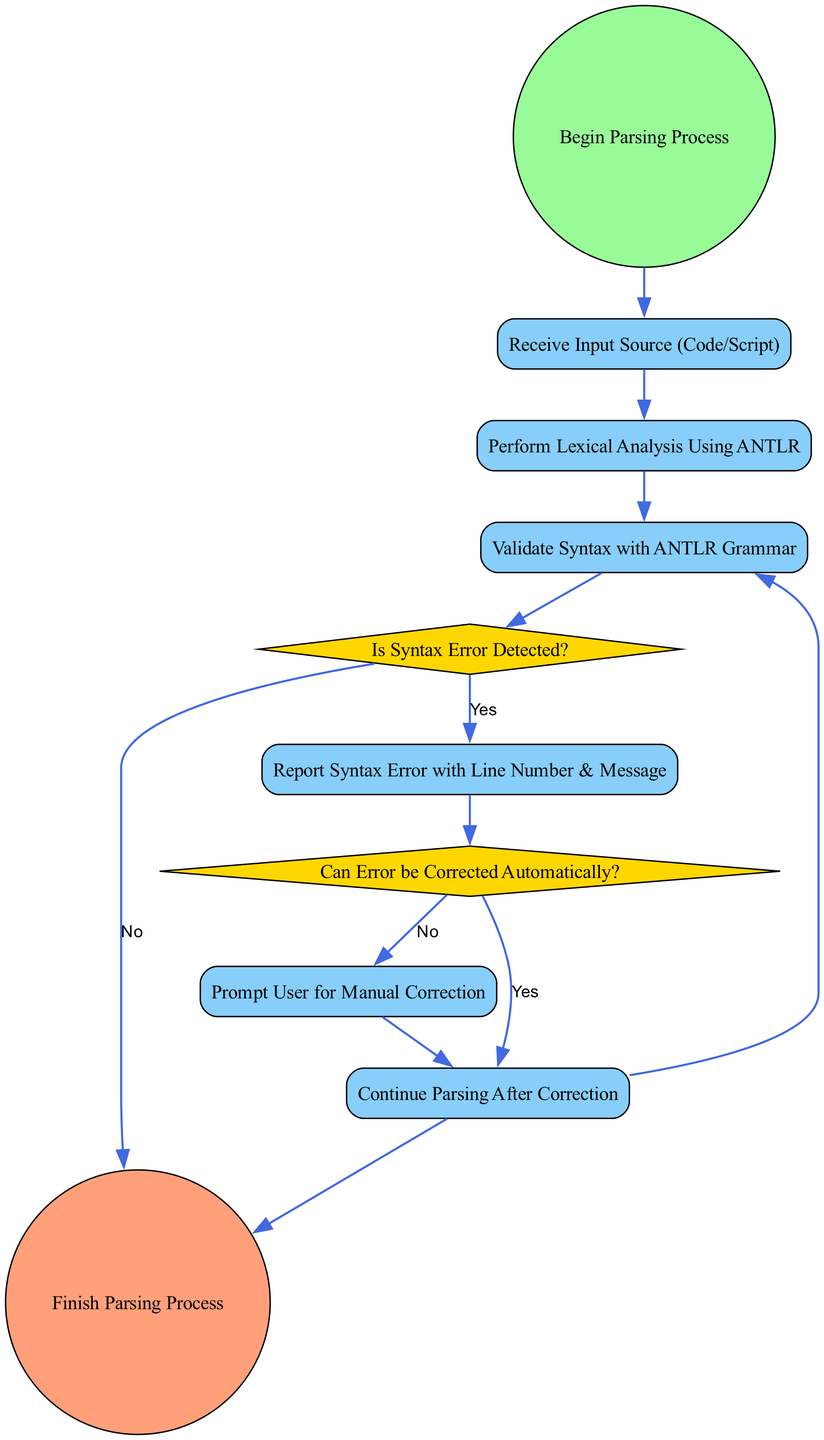What is the starting event in this flow chart? The starting event is clearly labeled as "Begin Parsing Process" which is represented by the node 'Start'.
Answer: Begin Parsing Process How many decision nodes are present in the diagram? Upon examining the diagram, there are two decision nodes: "Is Syntax Error Detected?" and "Can Error be Corrected Automatically?"
Answer: 2 Which task follows the completion of error reporting? According to the flow of the diagram, after "Error Reporting," the next task is "Correction Attempt."
Answer: Correction Attempt What happens when no syntax error is detected? In this scenario, the flow proceeds from "Error Found" directly to the "Completion" node, skipping error reporting.
Answer: Completion If an error can be corrected automatically, which node is the next step? In the flow diagram, if the answer to "Can Error be Corrected Automatically?" is yes, the next node to proceed to is "Continue Parsing."
Answer: Continue Parsing What action is taken if a syntax error is detected? The action taken is to report the syntax error, which is indicated by the connection from "Error Found" to "Error Reporting."
Answer: Report Syntax Error What type of node is the "Manual Correction" task? The "Manual Correction" task is classified as a Task node, which is depicted as a rectangle in the diagram.
Answer: Task How many tasks are there in the entire flow chart? After reviewing all nodes classified as tasks, there are five tasks: "Receive Input Source (Code/Script)," "Perform Lexical Analysis Using ANTLR," "Report Syntax Error with Line Number & Message," "Prompt User for Manual Correction," and "Continue Parsing After Correction."
Answer: 5 What happens after a manual correction is prompted? After prompting for manual correction, the flow continues to the "Continue Parsing" task, as indicated by the connection from "Manual Correction."
Answer: Continue Parsing 